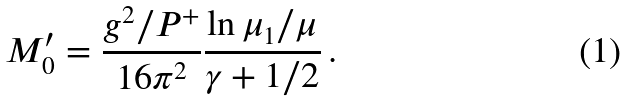Convert formula to latex. <formula><loc_0><loc_0><loc_500><loc_500>M ^ { \prime } _ { 0 } = \frac { g ^ { 2 } / P ^ { + } } { 1 6 \pi ^ { 2 } } \frac { \ln \mu _ { 1 } / \mu } { \gamma + 1 / 2 } \, .</formula> 